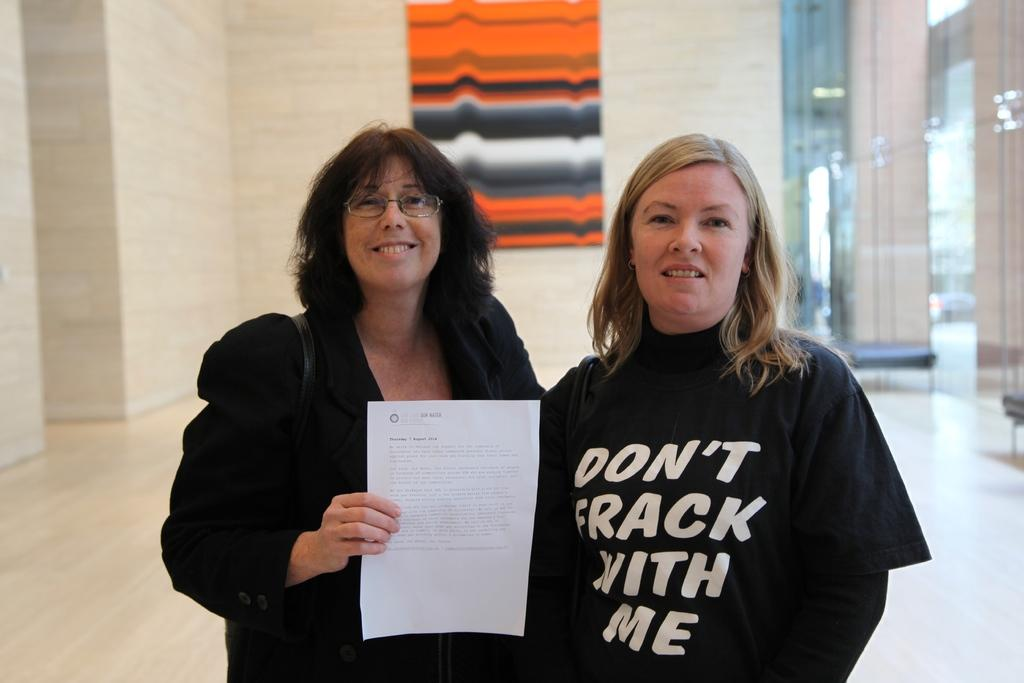How many people are in the image? There are two ladies in the image. What are the ladies wearing? The ladies are wearing black dresses. What can be seen in the background of the image? There is a wall in the background of the image. What type of power source is visible in the image? There is no power source visible in the image; it features two ladies wearing black dresses with a wall in the background. 